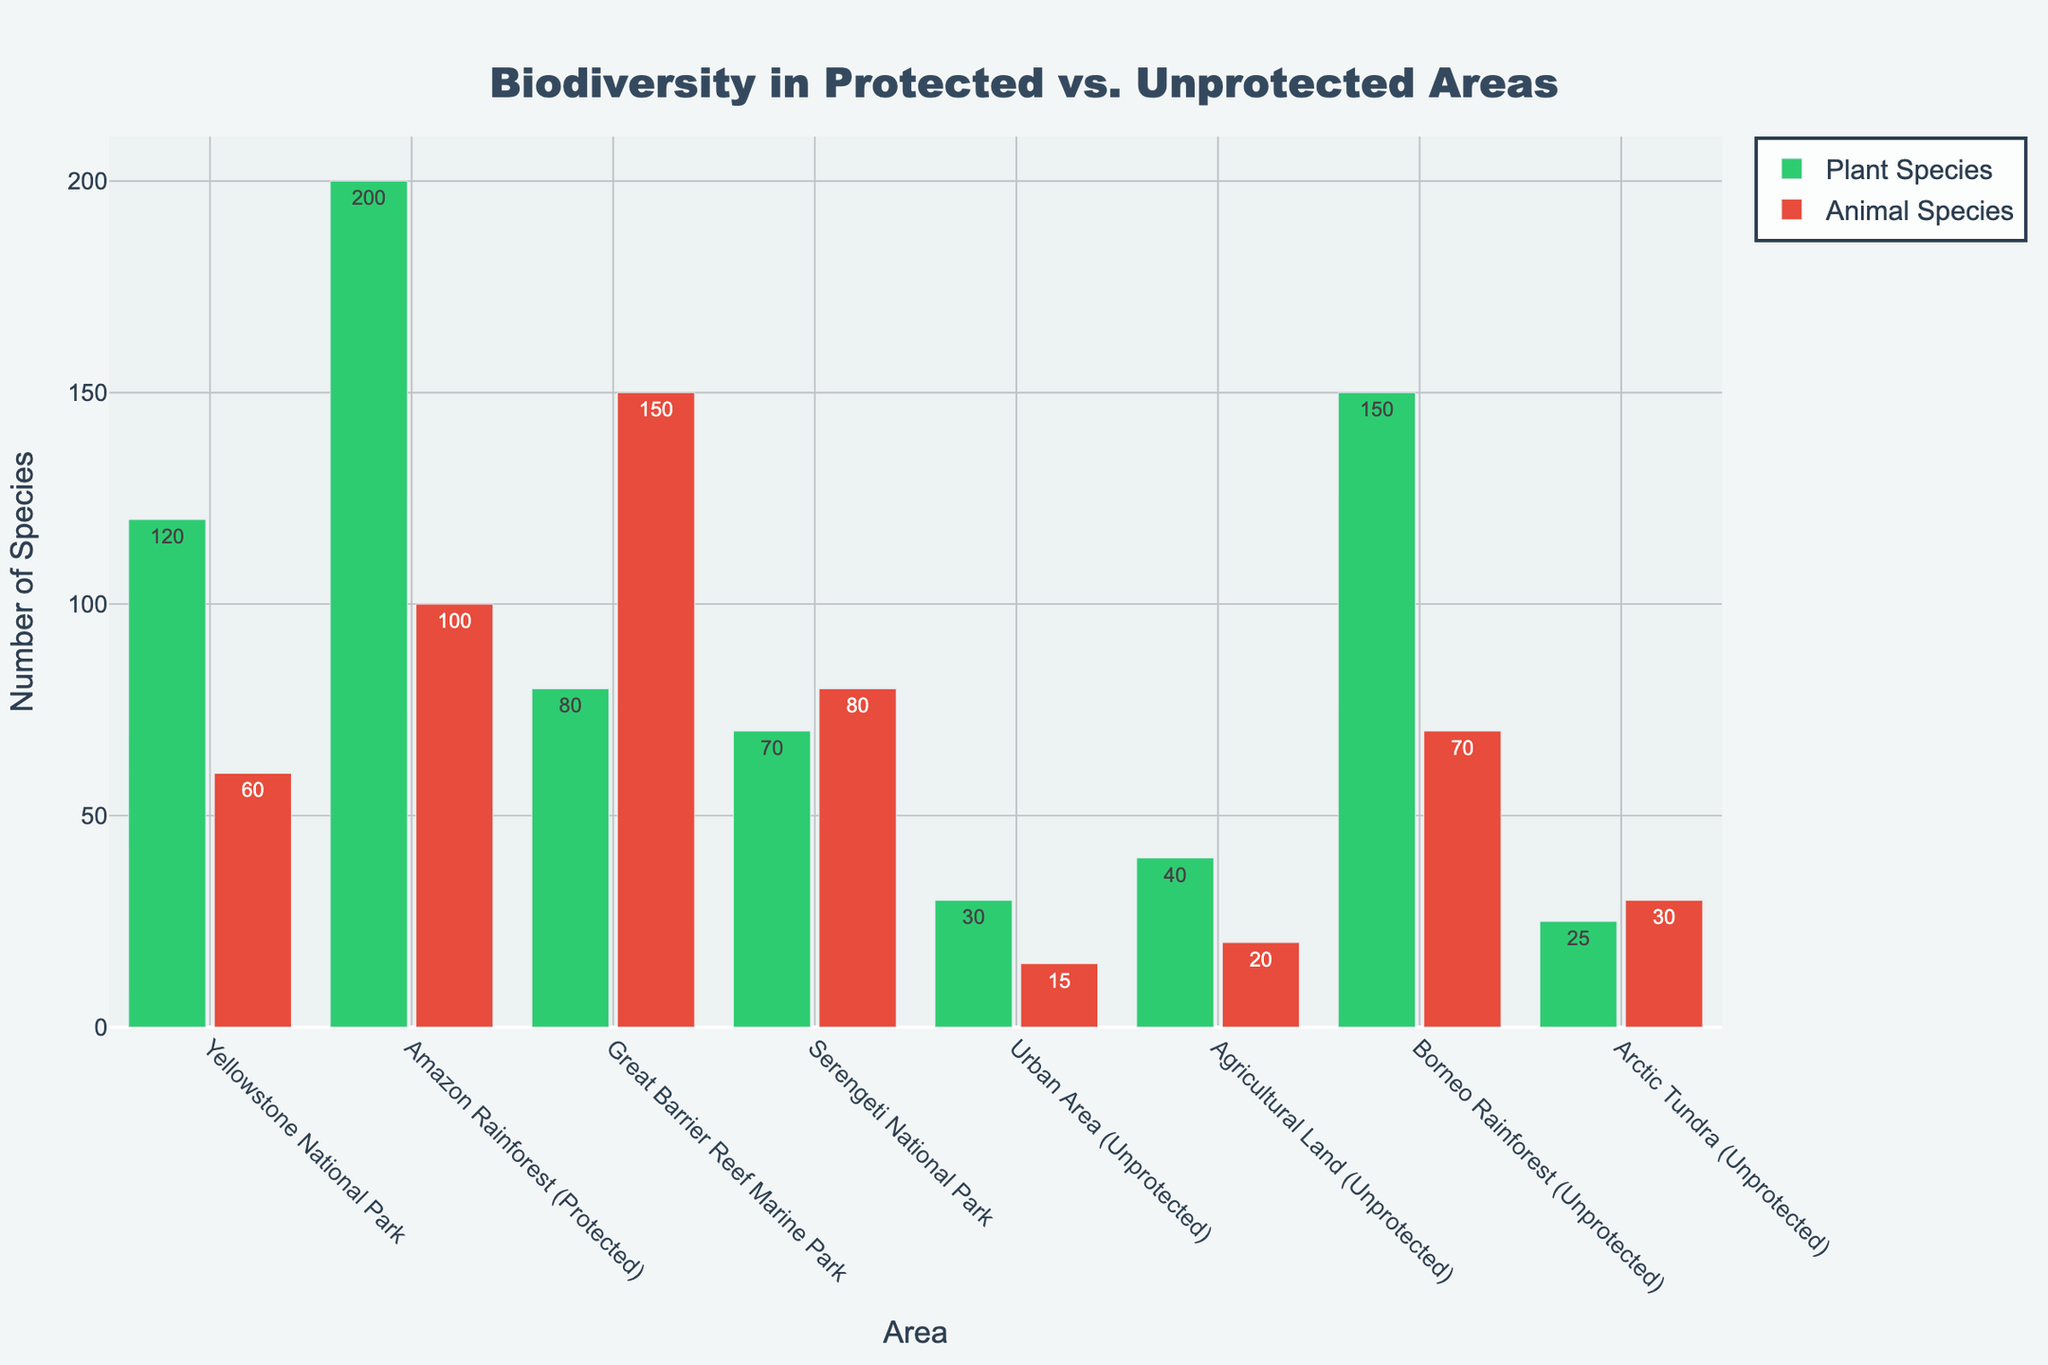what is the title of the figure? The title is centered at the top of the plot in large, bold text. It reads "Biodiversity in Protected vs. Unprotected Areas".
Answer: Biodiversity in Protected vs. Unprotected Areas How many total plant species are in urban areas? To find the total number of plant species in urban areas, locate the "Urban Area (Unprotected)" bar in the plant species group. The bar label shows 30 species.
Answer: 30 Which area has the highest number of animal species? Observe all the bars representing animal species across different areas. The area with the highest bar is "Great Barrier Reef Marine Park" with 150 species.
Answer: Great Barrier Reef Marine Park What is the difference between the number of plant species in the Amazon Rainforest (Protected) and Yellowstone National Park? Look at the bar heights or labels for the two areas: Amazon Rainforest has 200 plant species, and Yellowstone has 120. Calculate the difference: 200 - 120 = 80.
Answer: 80 Which area has a greater number of plant species, Borneo Rainforest or Serengeti National Park? Compare the bars for plant species in Borneo Rainforest and Serengeti National Park. Borneo Rainforest has 150 plant species while Serengeti National Park has 70.
Answer: Borneo Rainforest Is the number of animal species in agricultural land higher than in urban areas? Compare the bars for animal species in Agricultural Land and Urban Areas. Agricultural Land has 20 animal species, and Urban Areas have 15.
Answer: Yes What is the total number of species (plant and animal) in the Arctic Tundra? Sum the plant and animal species in the Arctic Tundra. There are 25 plant species and 30 animal species: 25 + 30 = 55.
Answer: 55 Which protected area has the least number of plant species? Look at the bars for plant species within the protected areas (Yellowstone National Park, Amazon Rainforest, Great Barrier Reef, and Serengeti National Park). Serengeti National Park has the least with 70 plant species.
Answer: Serengeti National Park Compare the number of plant species in the Arctic Tundra (unprotected) to the number of animal species in Yellowstone National Park (protected). Which is greater? The Arctic Tundra has 25 plant species, while Yellowstone National Park has 60 animal species. 60 is greater than 25.
Answer: Animal species in Yellowstone National Park What’s the average number of plant species across all unprotected areas? Identify the plant species counts in unprotected areas: Urban Area (30), Agricultural Land (40), Borneo Rainforest (150), Arctic Tundra (25). Sum them: 30 + 40 + 150 + 25 = 245. Divide by the number of unprotected areas (4): 245 / 4 = 61.25.
Answer: 61.25 